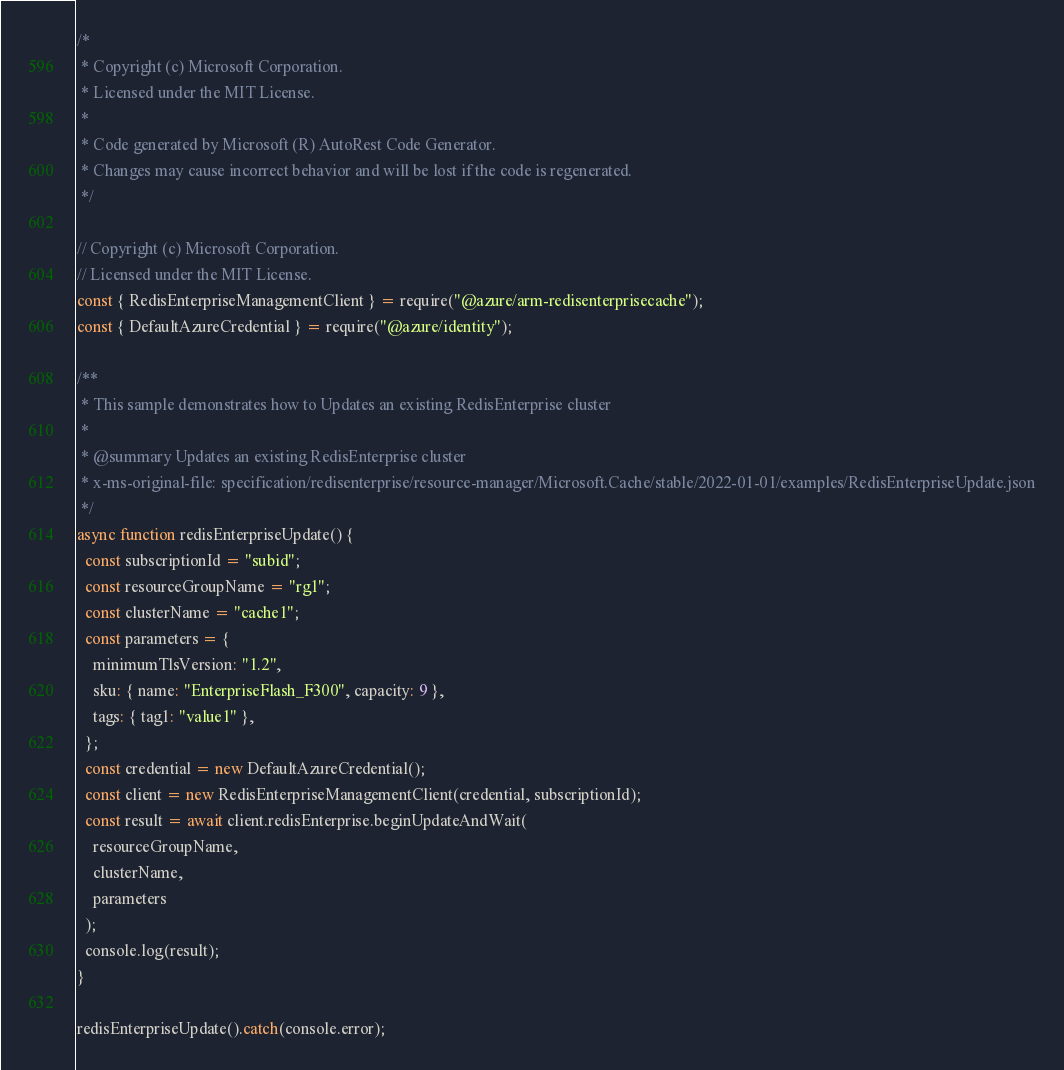<code> <loc_0><loc_0><loc_500><loc_500><_JavaScript_>/*
 * Copyright (c) Microsoft Corporation.
 * Licensed under the MIT License.
 *
 * Code generated by Microsoft (R) AutoRest Code Generator.
 * Changes may cause incorrect behavior and will be lost if the code is regenerated.
 */

// Copyright (c) Microsoft Corporation.
// Licensed under the MIT License.
const { RedisEnterpriseManagementClient } = require("@azure/arm-redisenterprisecache");
const { DefaultAzureCredential } = require("@azure/identity");

/**
 * This sample demonstrates how to Updates an existing RedisEnterprise cluster
 *
 * @summary Updates an existing RedisEnterprise cluster
 * x-ms-original-file: specification/redisenterprise/resource-manager/Microsoft.Cache/stable/2022-01-01/examples/RedisEnterpriseUpdate.json
 */
async function redisEnterpriseUpdate() {
  const subscriptionId = "subid";
  const resourceGroupName = "rg1";
  const clusterName = "cache1";
  const parameters = {
    minimumTlsVersion: "1.2",
    sku: { name: "EnterpriseFlash_F300", capacity: 9 },
    tags: { tag1: "value1" },
  };
  const credential = new DefaultAzureCredential();
  const client = new RedisEnterpriseManagementClient(credential, subscriptionId);
  const result = await client.redisEnterprise.beginUpdateAndWait(
    resourceGroupName,
    clusterName,
    parameters
  );
  console.log(result);
}

redisEnterpriseUpdate().catch(console.error);
</code> 